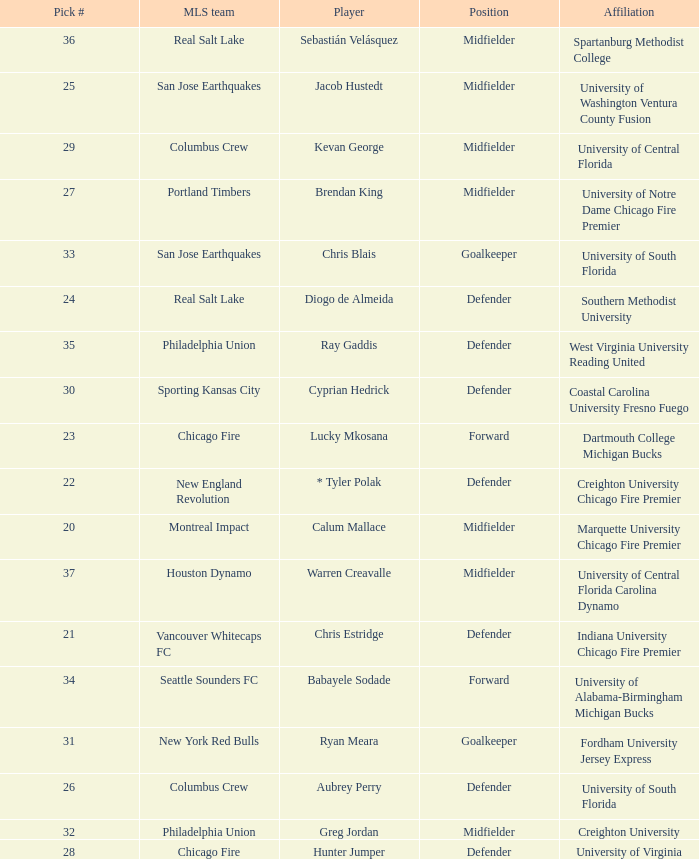What pick number did Real Salt Lake get? 24.0. 